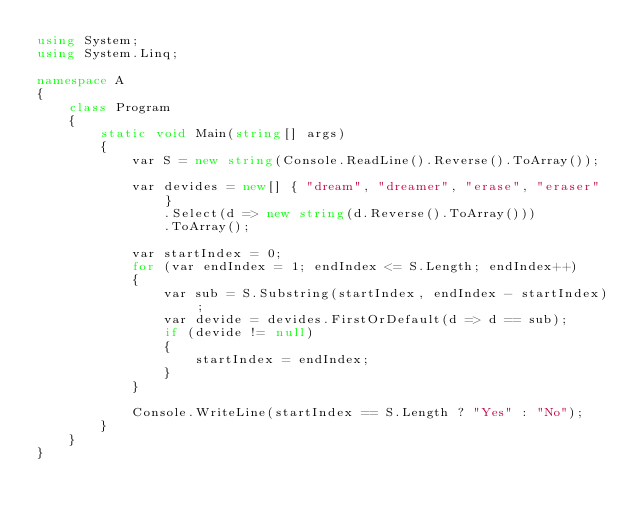<code> <loc_0><loc_0><loc_500><loc_500><_C#_>using System;
using System.Linq;

namespace A
{
    class Program
    {
        static void Main(string[] args)
        {
            var S = new string(Console.ReadLine().Reverse().ToArray());

            var devides = new[] { "dream", "dreamer", "erase", "eraser" }
                .Select(d => new string(d.Reverse().ToArray()))
                .ToArray();

            var startIndex = 0;
            for (var endIndex = 1; endIndex <= S.Length; endIndex++)
            {
                var sub = S.Substring(startIndex, endIndex - startIndex);
                var devide = devides.FirstOrDefault(d => d == sub);
                if (devide != null)
                {
                    startIndex = endIndex;
                }
            }

            Console.WriteLine(startIndex == S.Length ? "Yes" : "No");
        }
    }
}
</code> 